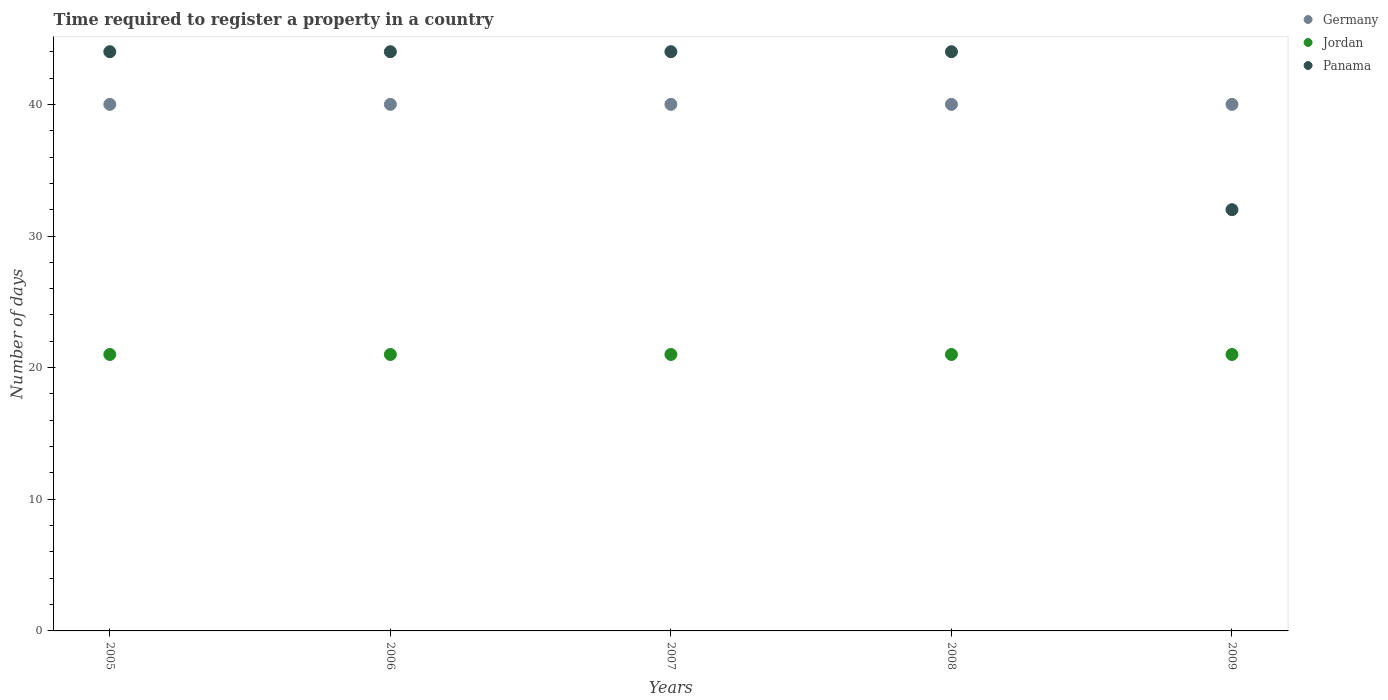Is the number of dotlines equal to the number of legend labels?
Offer a terse response. Yes. Across all years, what is the maximum number of days required to register a property in Jordan?
Provide a succinct answer. 21. Across all years, what is the minimum number of days required to register a property in Jordan?
Offer a very short reply. 21. In which year was the number of days required to register a property in Germany minimum?
Offer a very short reply. 2005. What is the total number of days required to register a property in Jordan in the graph?
Provide a short and direct response. 105. What is the difference between the number of days required to register a property in Germany in 2007 and the number of days required to register a property in Jordan in 2008?
Give a very brief answer. 19. What is the average number of days required to register a property in Panama per year?
Give a very brief answer. 41.6. In the year 2005, what is the difference between the number of days required to register a property in Jordan and number of days required to register a property in Germany?
Keep it short and to the point. -19. In how many years, is the number of days required to register a property in Germany greater than 24 days?
Keep it short and to the point. 5. What is the difference between the highest and the second highest number of days required to register a property in Jordan?
Your response must be concise. 0. Does the number of days required to register a property in Germany monotonically increase over the years?
Provide a short and direct response. No. Is the number of days required to register a property in Jordan strictly greater than the number of days required to register a property in Panama over the years?
Keep it short and to the point. No. Is the number of days required to register a property in Panama strictly less than the number of days required to register a property in Jordan over the years?
Your answer should be very brief. No. How many dotlines are there?
Your response must be concise. 3. What is the difference between two consecutive major ticks on the Y-axis?
Provide a short and direct response. 10. Does the graph contain grids?
Your answer should be compact. No. How many legend labels are there?
Your answer should be very brief. 3. How are the legend labels stacked?
Provide a short and direct response. Vertical. What is the title of the graph?
Ensure brevity in your answer.  Time required to register a property in a country. What is the label or title of the Y-axis?
Make the answer very short. Number of days. What is the Number of days of Germany in 2005?
Your response must be concise. 40. What is the Number of days in Jordan in 2005?
Ensure brevity in your answer.  21. What is the Number of days of Germany in 2006?
Give a very brief answer. 40. What is the Number of days of Jordan in 2006?
Keep it short and to the point. 21. What is the Number of days of Panama in 2006?
Offer a very short reply. 44. What is the Number of days in Germany in 2007?
Keep it short and to the point. 40. What is the Number of days of Panama in 2007?
Your answer should be compact. 44. What is the Number of days of Germany in 2008?
Offer a terse response. 40. What is the Number of days in Jordan in 2008?
Your answer should be compact. 21. What is the Number of days of Jordan in 2009?
Your answer should be very brief. 21. What is the Number of days of Panama in 2009?
Your response must be concise. 32. Across all years, what is the maximum Number of days of Panama?
Offer a very short reply. 44. Across all years, what is the minimum Number of days in Jordan?
Your response must be concise. 21. What is the total Number of days of Jordan in the graph?
Provide a succinct answer. 105. What is the total Number of days of Panama in the graph?
Offer a very short reply. 208. What is the difference between the Number of days of Panama in 2005 and that in 2007?
Your answer should be very brief. 0. What is the difference between the Number of days of Jordan in 2005 and that in 2009?
Provide a succinct answer. 0. What is the difference between the Number of days in Jordan in 2006 and that in 2007?
Provide a succinct answer. 0. What is the difference between the Number of days of Germany in 2006 and that in 2009?
Keep it short and to the point. 0. What is the difference between the Number of days in Germany in 2007 and that in 2008?
Give a very brief answer. 0. What is the difference between the Number of days of Jordan in 2007 and that in 2008?
Provide a short and direct response. 0. What is the difference between the Number of days in Jordan in 2007 and that in 2009?
Your response must be concise. 0. What is the difference between the Number of days of Panama in 2007 and that in 2009?
Provide a short and direct response. 12. What is the difference between the Number of days in Germany in 2008 and that in 2009?
Make the answer very short. 0. What is the difference between the Number of days of Jordan in 2008 and that in 2009?
Give a very brief answer. 0. What is the difference between the Number of days of Panama in 2008 and that in 2009?
Your answer should be compact. 12. What is the difference between the Number of days in Jordan in 2005 and the Number of days in Panama in 2006?
Your answer should be very brief. -23. What is the difference between the Number of days in Germany in 2005 and the Number of days in Jordan in 2007?
Your answer should be compact. 19. What is the difference between the Number of days in Germany in 2005 and the Number of days in Panama in 2009?
Your response must be concise. 8. What is the difference between the Number of days in Germany in 2006 and the Number of days in Jordan in 2008?
Ensure brevity in your answer.  19. What is the difference between the Number of days in Jordan in 2006 and the Number of days in Panama in 2009?
Provide a succinct answer. -11. What is the difference between the Number of days in Germany in 2008 and the Number of days in Jordan in 2009?
Offer a very short reply. 19. What is the difference between the Number of days in Germany in 2008 and the Number of days in Panama in 2009?
Make the answer very short. 8. What is the difference between the Number of days of Jordan in 2008 and the Number of days of Panama in 2009?
Provide a succinct answer. -11. What is the average Number of days in Jordan per year?
Give a very brief answer. 21. What is the average Number of days in Panama per year?
Your answer should be compact. 41.6. In the year 2005, what is the difference between the Number of days of Germany and Number of days of Jordan?
Offer a terse response. 19. In the year 2005, what is the difference between the Number of days of Germany and Number of days of Panama?
Give a very brief answer. -4. In the year 2006, what is the difference between the Number of days in Germany and Number of days in Jordan?
Offer a very short reply. 19. In the year 2006, what is the difference between the Number of days in Germany and Number of days in Panama?
Offer a very short reply. -4. In the year 2006, what is the difference between the Number of days in Jordan and Number of days in Panama?
Ensure brevity in your answer.  -23. In the year 2007, what is the difference between the Number of days in Germany and Number of days in Jordan?
Offer a terse response. 19. In the year 2008, what is the difference between the Number of days of Germany and Number of days of Jordan?
Offer a very short reply. 19. In the year 2008, what is the difference between the Number of days in Germany and Number of days in Panama?
Keep it short and to the point. -4. In the year 2009, what is the difference between the Number of days in Jordan and Number of days in Panama?
Give a very brief answer. -11. What is the ratio of the Number of days of Germany in 2005 to that in 2006?
Your answer should be very brief. 1. What is the ratio of the Number of days of Panama in 2005 to that in 2006?
Provide a succinct answer. 1. What is the ratio of the Number of days of Germany in 2005 to that in 2007?
Provide a short and direct response. 1. What is the ratio of the Number of days in Jordan in 2005 to that in 2007?
Make the answer very short. 1. What is the ratio of the Number of days of Germany in 2005 to that in 2008?
Ensure brevity in your answer.  1. What is the ratio of the Number of days of Jordan in 2005 to that in 2008?
Offer a very short reply. 1. What is the ratio of the Number of days in Germany in 2005 to that in 2009?
Make the answer very short. 1. What is the ratio of the Number of days in Jordan in 2005 to that in 2009?
Provide a succinct answer. 1. What is the ratio of the Number of days of Panama in 2005 to that in 2009?
Offer a very short reply. 1.38. What is the ratio of the Number of days of Panama in 2006 to that in 2007?
Ensure brevity in your answer.  1. What is the ratio of the Number of days of Germany in 2006 to that in 2008?
Make the answer very short. 1. What is the ratio of the Number of days of Jordan in 2006 to that in 2008?
Make the answer very short. 1. What is the ratio of the Number of days in Panama in 2006 to that in 2008?
Keep it short and to the point. 1. What is the ratio of the Number of days of Jordan in 2006 to that in 2009?
Offer a very short reply. 1. What is the ratio of the Number of days of Panama in 2006 to that in 2009?
Give a very brief answer. 1.38. What is the ratio of the Number of days of Panama in 2007 to that in 2009?
Provide a succinct answer. 1.38. What is the ratio of the Number of days of Panama in 2008 to that in 2009?
Your response must be concise. 1.38. What is the difference between the highest and the lowest Number of days in Germany?
Make the answer very short. 0. What is the difference between the highest and the lowest Number of days of Jordan?
Provide a succinct answer. 0. What is the difference between the highest and the lowest Number of days in Panama?
Your answer should be very brief. 12. 